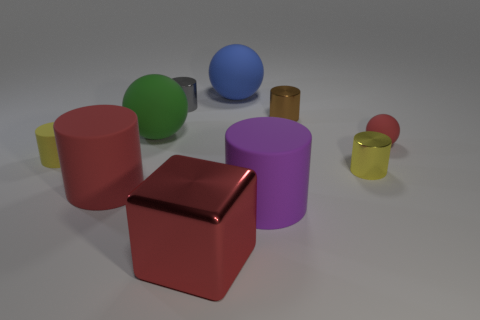Subtract all cyan balls. How many yellow cylinders are left? 2 Subtract all blue rubber spheres. How many spheres are left? 2 Subtract all blue balls. How many balls are left? 2 Subtract 0 blue cylinders. How many objects are left? 10 Subtract all blocks. How many objects are left? 9 Subtract 3 spheres. How many spheres are left? 0 Subtract all green cubes. Subtract all green balls. How many cubes are left? 1 Subtract all small yellow things. Subtract all red cubes. How many objects are left? 7 Add 3 tiny gray shiny things. How many tiny gray shiny things are left? 4 Add 2 small brown rubber blocks. How many small brown rubber blocks exist? 2 